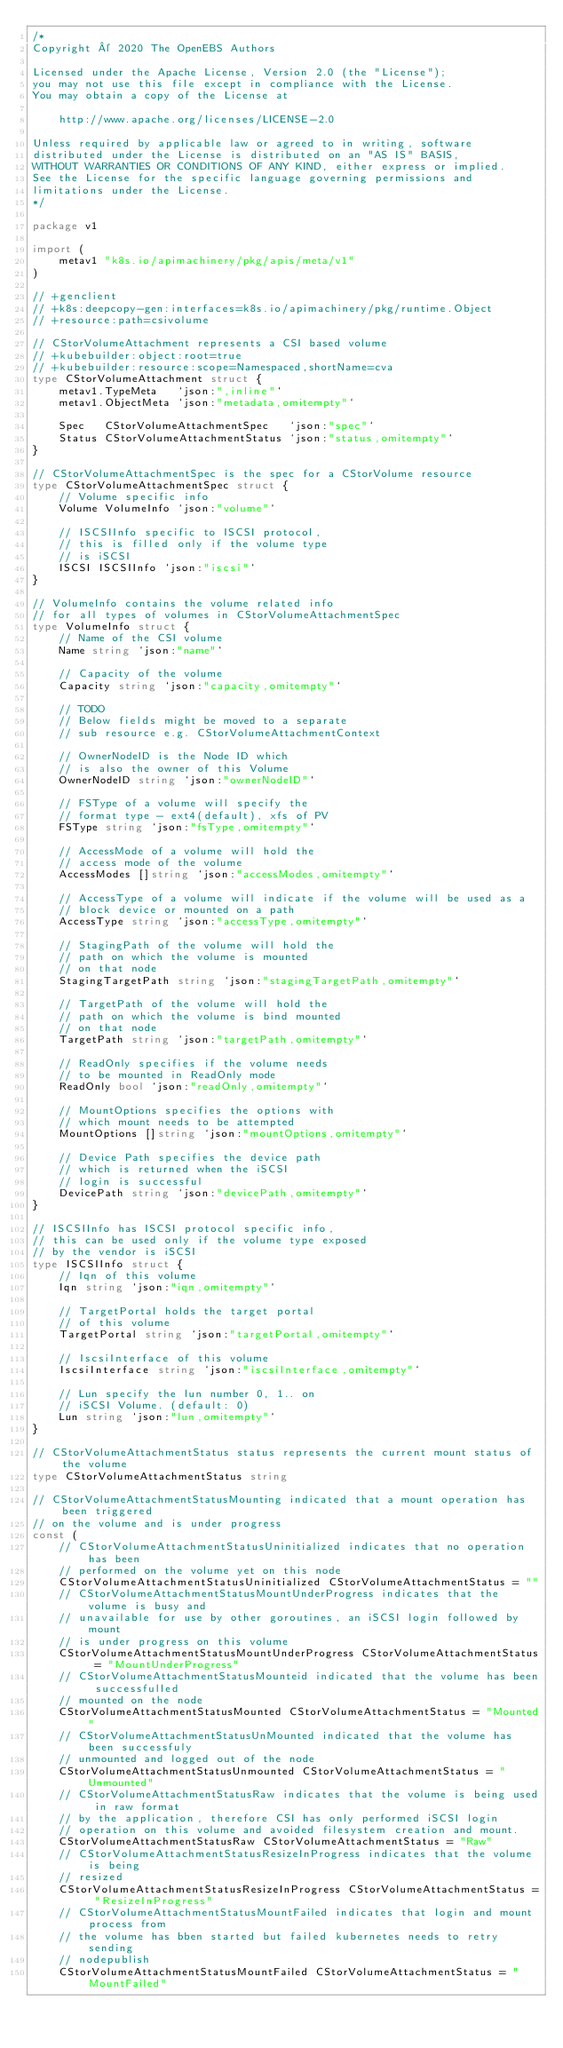Convert code to text. <code><loc_0><loc_0><loc_500><loc_500><_Go_>/*
Copyright © 2020 The OpenEBS Authors

Licensed under the Apache License, Version 2.0 (the "License");
you may not use this file except in compliance with the License.
You may obtain a copy of the License at

    http://www.apache.org/licenses/LICENSE-2.0

Unless required by applicable law or agreed to in writing, software
distributed under the License is distributed on an "AS IS" BASIS,
WITHOUT WARRANTIES OR CONDITIONS OF ANY KIND, either express or implied.
See the License for the specific language governing permissions and
limitations under the License.
*/

package v1

import (
	metav1 "k8s.io/apimachinery/pkg/apis/meta/v1"
)

// +genclient
// +k8s:deepcopy-gen:interfaces=k8s.io/apimachinery/pkg/runtime.Object
// +resource:path=csivolume

// CStorVolumeAttachment represents a CSI based volume
// +kubebuilder:object:root=true
// +kubebuilder:resource:scope=Namespaced,shortName=cva
type CStorVolumeAttachment struct {
	metav1.TypeMeta   `json:",inline"`
	metav1.ObjectMeta `json:"metadata,omitempty"`

	Spec   CStorVolumeAttachmentSpec   `json:"spec"`
	Status CStorVolumeAttachmentStatus `json:"status,omitempty"`
}

// CStorVolumeAttachmentSpec is the spec for a CStorVolume resource
type CStorVolumeAttachmentSpec struct {
	// Volume specific info
	Volume VolumeInfo `json:"volume"`

	// ISCSIInfo specific to ISCSI protocol,
	// this is filled only if the volume type
	// is iSCSI
	ISCSI ISCSIInfo `json:"iscsi"`
}

// VolumeInfo contains the volume related info
// for all types of volumes in CStorVolumeAttachmentSpec
type VolumeInfo struct {
	// Name of the CSI volume
	Name string `json:"name"`

	// Capacity of the volume
	Capacity string `json:"capacity,omitempty"`

	// TODO
	// Below fields might be moved to a separate
	// sub resource e.g. CStorVolumeAttachmentContext

	// OwnerNodeID is the Node ID which
	// is also the owner of this Volume
	OwnerNodeID string `json:"ownerNodeID"`

	// FSType of a volume will specify the
	// format type - ext4(default), xfs of PV
	FSType string `json:"fsType,omitempty"`

	// AccessMode of a volume will hold the
	// access mode of the volume
	AccessModes []string `json:"accessModes,omitempty"`

	// AccessType of a volume will indicate if the volume will be used as a
	// block device or mounted on a path
	AccessType string `json:"accessType,omitempty"`

	// StagingPath of the volume will hold the
	// path on which the volume is mounted
	// on that node
	StagingTargetPath string `json:"stagingTargetPath,omitempty"`

	// TargetPath of the volume will hold the
	// path on which the volume is bind mounted
	// on that node
	TargetPath string `json:"targetPath,omitempty"`

	// ReadOnly specifies if the volume needs
	// to be mounted in ReadOnly mode
	ReadOnly bool `json:"readOnly,omitempty"`

	// MountOptions specifies the options with
	// which mount needs to be attempted
	MountOptions []string `json:"mountOptions,omitempty"`

	// Device Path specifies the device path
	// which is returned when the iSCSI
	// login is successful
	DevicePath string `json:"devicePath,omitempty"`
}

// ISCSIInfo has ISCSI protocol specific info,
// this can be used only if the volume type exposed
// by the vendor is iSCSI
type ISCSIInfo struct {
	// Iqn of this volume
	Iqn string `json:"iqn,omitempty"`

	// TargetPortal holds the target portal
	// of this volume
	TargetPortal string `json:"targetPortal,omitempty"`

	// IscsiInterface of this volume
	IscsiInterface string `json:"iscsiInterface,omitempty"`

	// Lun specify the lun number 0, 1.. on
	// iSCSI Volume. (default: 0)
	Lun string `json:"lun,omitempty"`
}

// CStorVolumeAttachmentStatus status represents the current mount status of the volume
type CStorVolumeAttachmentStatus string

// CStorVolumeAttachmentStatusMounting indicated that a mount operation has been triggered
// on the volume and is under progress
const (
	// CStorVolumeAttachmentStatusUninitialized indicates that no operation has been
	// performed on the volume yet on this node
	CStorVolumeAttachmentStatusUninitialized CStorVolumeAttachmentStatus = ""
	// CStorVolumeAttachmentStatusMountUnderProgress indicates that the volume is busy and
	// unavailable for use by other goroutines, an iSCSI login followed by mount
	// is under progress on this volume
	CStorVolumeAttachmentStatusMountUnderProgress CStorVolumeAttachmentStatus = "MountUnderProgress"
	// CStorVolumeAttachmentStatusMounteid indicated that the volume has been successfulled
	// mounted on the node
	CStorVolumeAttachmentStatusMounted CStorVolumeAttachmentStatus = "Mounted"
	// CStorVolumeAttachmentStatusUnMounted indicated that the volume has been successfuly
	// unmounted and logged out of the node
	CStorVolumeAttachmentStatusUnmounted CStorVolumeAttachmentStatus = "Unmounted"
	// CStorVolumeAttachmentStatusRaw indicates that the volume is being used in raw format
	// by the application, therefore CSI has only performed iSCSI login
	// operation on this volume and avoided filesystem creation and mount.
	CStorVolumeAttachmentStatusRaw CStorVolumeAttachmentStatus = "Raw"
	// CStorVolumeAttachmentStatusResizeInProgress indicates that the volume is being
	// resized
	CStorVolumeAttachmentStatusResizeInProgress CStorVolumeAttachmentStatus = "ResizeInProgress"
	// CStorVolumeAttachmentStatusMountFailed indicates that login and mount process from
	// the volume has bben started but failed kubernetes needs to retry sending
	// nodepublish
	CStorVolumeAttachmentStatusMountFailed CStorVolumeAttachmentStatus = "MountFailed"</code> 